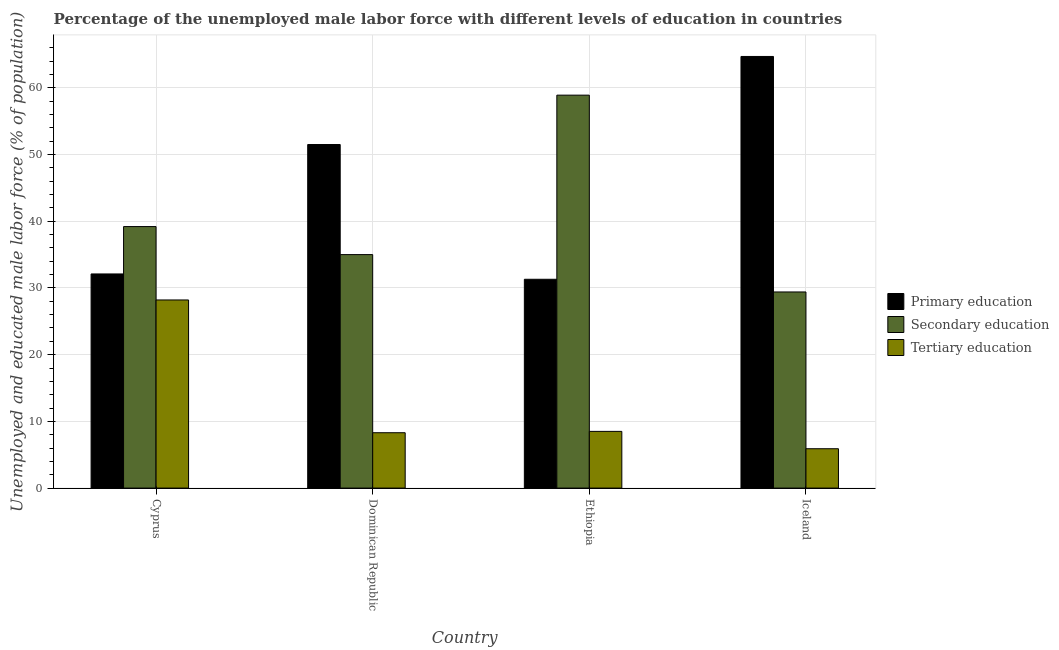How many groups of bars are there?
Give a very brief answer. 4. How many bars are there on the 3rd tick from the left?
Offer a very short reply. 3. In how many cases, is the number of bars for a given country not equal to the number of legend labels?
Provide a short and direct response. 0. What is the percentage of male labor force who received tertiary education in Dominican Republic?
Give a very brief answer. 8.3. Across all countries, what is the maximum percentage of male labor force who received primary education?
Your response must be concise. 64.7. Across all countries, what is the minimum percentage of male labor force who received tertiary education?
Provide a succinct answer. 5.9. In which country was the percentage of male labor force who received secondary education maximum?
Your answer should be compact. Ethiopia. What is the total percentage of male labor force who received primary education in the graph?
Your answer should be compact. 179.6. What is the difference between the percentage of male labor force who received primary education in Cyprus and that in Dominican Republic?
Your response must be concise. -19.4. What is the difference between the percentage of male labor force who received tertiary education in Cyprus and the percentage of male labor force who received primary education in Dominican Republic?
Ensure brevity in your answer.  -23.3. What is the average percentage of male labor force who received primary education per country?
Give a very brief answer. 44.9. What is the difference between the percentage of male labor force who received primary education and percentage of male labor force who received secondary education in Ethiopia?
Ensure brevity in your answer.  -27.6. What is the ratio of the percentage of male labor force who received tertiary education in Dominican Republic to that in Iceland?
Ensure brevity in your answer.  1.41. Is the percentage of male labor force who received secondary education in Cyprus less than that in Iceland?
Your answer should be compact. No. What is the difference between the highest and the second highest percentage of male labor force who received secondary education?
Your answer should be very brief. 19.7. What is the difference between the highest and the lowest percentage of male labor force who received secondary education?
Keep it short and to the point. 29.5. In how many countries, is the percentage of male labor force who received tertiary education greater than the average percentage of male labor force who received tertiary education taken over all countries?
Make the answer very short. 1. Is the sum of the percentage of male labor force who received tertiary education in Cyprus and Iceland greater than the maximum percentage of male labor force who received secondary education across all countries?
Give a very brief answer. No. What does the 1st bar from the left in Iceland represents?
Ensure brevity in your answer.  Primary education. What does the 3rd bar from the right in Iceland represents?
Make the answer very short. Primary education. How many bars are there?
Your answer should be very brief. 12. How many countries are there in the graph?
Your response must be concise. 4. Are the values on the major ticks of Y-axis written in scientific E-notation?
Your response must be concise. No. Does the graph contain any zero values?
Keep it short and to the point. No. How many legend labels are there?
Offer a very short reply. 3. What is the title of the graph?
Provide a succinct answer. Percentage of the unemployed male labor force with different levels of education in countries. Does "Ages 50+" appear as one of the legend labels in the graph?
Provide a succinct answer. No. What is the label or title of the X-axis?
Give a very brief answer. Country. What is the label or title of the Y-axis?
Offer a very short reply. Unemployed and educated male labor force (% of population). What is the Unemployed and educated male labor force (% of population) of Primary education in Cyprus?
Make the answer very short. 32.1. What is the Unemployed and educated male labor force (% of population) in Secondary education in Cyprus?
Provide a short and direct response. 39.2. What is the Unemployed and educated male labor force (% of population) of Tertiary education in Cyprus?
Your answer should be compact. 28.2. What is the Unemployed and educated male labor force (% of population) in Primary education in Dominican Republic?
Give a very brief answer. 51.5. What is the Unemployed and educated male labor force (% of population) in Secondary education in Dominican Republic?
Your answer should be very brief. 35. What is the Unemployed and educated male labor force (% of population) in Tertiary education in Dominican Republic?
Your answer should be compact. 8.3. What is the Unemployed and educated male labor force (% of population) of Primary education in Ethiopia?
Give a very brief answer. 31.3. What is the Unemployed and educated male labor force (% of population) in Secondary education in Ethiopia?
Your response must be concise. 58.9. What is the Unemployed and educated male labor force (% of population) in Tertiary education in Ethiopia?
Your answer should be very brief. 8.5. What is the Unemployed and educated male labor force (% of population) in Primary education in Iceland?
Ensure brevity in your answer.  64.7. What is the Unemployed and educated male labor force (% of population) in Secondary education in Iceland?
Give a very brief answer. 29.4. What is the Unemployed and educated male labor force (% of population) in Tertiary education in Iceland?
Provide a short and direct response. 5.9. Across all countries, what is the maximum Unemployed and educated male labor force (% of population) in Primary education?
Your response must be concise. 64.7. Across all countries, what is the maximum Unemployed and educated male labor force (% of population) of Secondary education?
Ensure brevity in your answer.  58.9. Across all countries, what is the maximum Unemployed and educated male labor force (% of population) in Tertiary education?
Your response must be concise. 28.2. Across all countries, what is the minimum Unemployed and educated male labor force (% of population) of Primary education?
Your answer should be very brief. 31.3. Across all countries, what is the minimum Unemployed and educated male labor force (% of population) in Secondary education?
Your answer should be very brief. 29.4. Across all countries, what is the minimum Unemployed and educated male labor force (% of population) of Tertiary education?
Your response must be concise. 5.9. What is the total Unemployed and educated male labor force (% of population) in Primary education in the graph?
Offer a terse response. 179.6. What is the total Unemployed and educated male labor force (% of population) of Secondary education in the graph?
Give a very brief answer. 162.5. What is the total Unemployed and educated male labor force (% of population) of Tertiary education in the graph?
Offer a terse response. 50.9. What is the difference between the Unemployed and educated male labor force (% of population) of Primary education in Cyprus and that in Dominican Republic?
Provide a short and direct response. -19.4. What is the difference between the Unemployed and educated male labor force (% of population) of Secondary education in Cyprus and that in Dominican Republic?
Your response must be concise. 4.2. What is the difference between the Unemployed and educated male labor force (% of population) in Secondary education in Cyprus and that in Ethiopia?
Your response must be concise. -19.7. What is the difference between the Unemployed and educated male labor force (% of population) of Primary education in Cyprus and that in Iceland?
Provide a short and direct response. -32.6. What is the difference between the Unemployed and educated male labor force (% of population) of Tertiary education in Cyprus and that in Iceland?
Your answer should be very brief. 22.3. What is the difference between the Unemployed and educated male labor force (% of population) of Primary education in Dominican Republic and that in Ethiopia?
Keep it short and to the point. 20.2. What is the difference between the Unemployed and educated male labor force (% of population) of Secondary education in Dominican Republic and that in Ethiopia?
Make the answer very short. -23.9. What is the difference between the Unemployed and educated male labor force (% of population) in Primary education in Dominican Republic and that in Iceland?
Your response must be concise. -13.2. What is the difference between the Unemployed and educated male labor force (% of population) in Primary education in Ethiopia and that in Iceland?
Your response must be concise. -33.4. What is the difference between the Unemployed and educated male labor force (% of population) in Secondary education in Ethiopia and that in Iceland?
Keep it short and to the point. 29.5. What is the difference between the Unemployed and educated male labor force (% of population) of Tertiary education in Ethiopia and that in Iceland?
Give a very brief answer. 2.6. What is the difference between the Unemployed and educated male labor force (% of population) in Primary education in Cyprus and the Unemployed and educated male labor force (% of population) in Secondary education in Dominican Republic?
Your response must be concise. -2.9. What is the difference between the Unemployed and educated male labor force (% of population) in Primary education in Cyprus and the Unemployed and educated male labor force (% of population) in Tertiary education in Dominican Republic?
Your answer should be compact. 23.8. What is the difference between the Unemployed and educated male labor force (% of population) in Secondary education in Cyprus and the Unemployed and educated male labor force (% of population) in Tertiary education in Dominican Republic?
Offer a terse response. 30.9. What is the difference between the Unemployed and educated male labor force (% of population) of Primary education in Cyprus and the Unemployed and educated male labor force (% of population) of Secondary education in Ethiopia?
Provide a short and direct response. -26.8. What is the difference between the Unemployed and educated male labor force (% of population) of Primary education in Cyprus and the Unemployed and educated male labor force (% of population) of Tertiary education in Ethiopia?
Make the answer very short. 23.6. What is the difference between the Unemployed and educated male labor force (% of population) in Secondary education in Cyprus and the Unemployed and educated male labor force (% of population) in Tertiary education in Ethiopia?
Provide a short and direct response. 30.7. What is the difference between the Unemployed and educated male labor force (% of population) in Primary education in Cyprus and the Unemployed and educated male labor force (% of population) in Secondary education in Iceland?
Give a very brief answer. 2.7. What is the difference between the Unemployed and educated male labor force (% of population) of Primary education in Cyprus and the Unemployed and educated male labor force (% of population) of Tertiary education in Iceland?
Your answer should be very brief. 26.2. What is the difference between the Unemployed and educated male labor force (% of population) of Secondary education in Cyprus and the Unemployed and educated male labor force (% of population) of Tertiary education in Iceland?
Offer a very short reply. 33.3. What is the difference between the Unemployed and educated male labor force (% of population) of Primary education in Dominican Republic and the Unemployed and educated male labor force (% of population) of Secondary education in Ethiopia?
Offer a terse response. -7.4. What is the difference between the Unemployed and educated male labor force (% of population) in Primary education in Dominican Republic and the Unemployed and educated male labor force (% of population) in Secondary education in Iceland?
Provide a short and direct response. 22.1. What is the difference between the Unemployed and educated male labor force (% of population) in Primary education in Dominican Republic and the Unemployed and educated male labor force (% of population) in Tertiary education in Iceland?
Keep it short and to the point. 45.6. What is the difference between the Unemployed and educated male labor force (% of population) of Secondary education in Dominican Republic and the Unemployed and educated male labor force (% of population) of Tertiary education in Iceland?
Provide a short and direct response. 29.1. What is the difference between the Unemployed and educated male labor force (% of population) of Primary education in Ethiopia and the Unemployed and educated male labor force (% of population) of Secondary education in Iceland?
Keep it short and to the point. 1.9. What is the difference between the Unemployed and educated male labor force (% of population) in Primary education in Ethiopia and the Unemployed and educated male labor force (% of population) in Tertiary education in Iceland?
Your answer should be very brief. 25.4. What is the difference between the Unemployed and educated male labor force (% of population) in Secondary education in Ethiopia and the Unemployed and educated male labor force (% of population) in Tertiary education in Iceland?
Provide a succinct answer. 53. What is the average Unemployed and educated male labor force (% of population) in Primary education per country?
Give a very brief answer. 44.9. What is the average Unemployed and educated male labor force (% of population) of Secondary education per country?
Your response must be concise. 40.62. What is the average Unemployed and educated male labor force (% of population) in Tertiary education per country?
Offer a very short reply. 12.72. What is the difference between the Unemployed and educated male labor force (% of population) of Primary education and Unemployed and educated male labor force (% of population) of Tertiary education in Dominican Republic?
Provide a short and direct response. 43.2. What is the difference between the Unemployed and educated male labor force (% of population) of Secondary education and Unemployed and educated male labor force (% of population) of Tertiary education in Dominican Republic?
Give a very brief answer. 26.7. What is the difference between the Unemployed and educated male labor force (% of population) in Primary education and Unemployed and educated male labor force (% of population) in Secondary education in Ethiopia?
Your answer should be very brief. -27.6. What is the difference between the Unemployed and educated male labor force (% of population) of Primary education and Unemployed and educated male labor force (% of population) of Tertiary education in Ethiopia?
Your answer should be very brief. 22.8. What is the difference between the Unemployed and educated male labor force (% of population) in Secondary education and Unemployed and educated male labor force (% of population) in Tertiary education in Ethiopia?
Your answer should be very brief. 50.4. What is the difference between the Unemployed and educated male labor force (% of population) of Primary education and Unemployed and educated male labor force (% of population) of Secondary education in Iceland?
Offer a terse response. 35.3. What is the difference between the Unemployed and educated male labor force (% of population) of Primary education and Unemployed and educated male labor force (% of population) of Tertiary education in Iceland?
Make the answer very short. 58.8. What is the difference between the Unemployed and educated male labor force (% of population) in Secondary education and Unemployed and educated male labor force (% of population) in Tertiary education in Iceland?
Provide a succinct answer. 23.5. What is the ratio of the Unemployed and educated male labor force (% of population) in Primary education in Cyprus to that in Dominican Republic?
Provide a short and direct response. 0.62. What is the ratio of the Unemployed and educated male labor force (% of population) of Secondary education in Cyprus to that in Dominican Republic?
Make the answer very short. 1.12. What is the ratio of the Unemployed and educated male labor force (% of population) of Tertiary education in Cyprus to that in Dominican Republic?
Provide a succinct answer. 3.4. What is the ratio of the Unemployed and educated male labor force (% of population) of Primary education in Cyprus to that in Ethiopia?
Offer a very short reply. 1.03. What is the ratio of the Unemployed and educated male labor force (% of population) of Secondary education in Cyprus to that in Ethiopia?
Offer a very short reply. 0.67. What is the ratio of the Unemployed and educated male labor force (% of population) of Tertiary education in Cyprus to that in Ethiopia?
Provide a succinct answer. 3.32. What is the ratio of the Unemployed and educated male labor force (% of population) in Primary education in Cyprus to that in Iceland?
Keep it short and to the point. 0.5. What is the ratio of the Unemployed and educated male labor force (% of population) of Secondary education in Cyprus to that in Iceland?
Your response must be concise. 1.33. What is the ratio of the Unemployed and educated male labor force (% of population) in Tertiary education in Cyprus to that in Iceland?
Your answer should be very brief. 4.78. What is the ratio of the Unemployed and educated male labor force (% of population) in Primary education in Dominican Republic to that in Ethiopia?
Ensure brevity in your answer.  1.65. What is the ratio of the Unemployed and educated male labor force (% of population) in Secondary education in Dominican Republic to that in Ethiopia?
Provide a short and direct response. 0.59. What is the ratio of the Unemployed and educated male labor force (% of population) of Tertiary education in Dominican Republic to that in Ethiopia?
Provide a short and direct response. 0.98. What is the ratio of the Unemployed and educated male labor force (% of population) of Primary education in Dominican Republic to that in Iceland?
Offer a terse response. 0.8. What is the ratio of the Unemployed and educated male labor force (% of population) of Secondary education in Dominican Republic to that in Iceland?
Your response must be concise. 1.19. What is the ratio of the Unemployed and educated male labor force (% of population) in Tertiary education in Dominican Republic to that in Iceland?
Keep it short and to the point. 1.41. What is the ratio of the Unemployed and educated male labor force (% of population) in Primary education in Ethiopia to that in Iceland?
Keep it short and to the point. 0.48. What is the ratio of the Unemployed and educated male labor force (% of population) of Secondary education in Ethiopia to that in Iceland?
Your answer should be very brief. 2. What is the ratio of the Unemployed and educated male labor force (% of population) in Tertiary education in Ethiopia to that in Iceland?
Provide a short and direct response. 1.44. What is the difference between the highest and the second highest Unemployed and educated male labor force (% of population) of Primary education?
Make the answer very short. 13.2. What is the difference between the highest and the second highest Unemployed and educated male labor force (% of population) of Secondary education?
Your answer should be compact. 19.7. What is the difference between the highest and the lowest Unemployed and educated male labor force (% of population) in Primary education?
Make the answer very short. 33.4. What is the difference between the highest and the lowest Unemployed and educated male labor force (% of population) in Secondary education?
Offer a terse response. 29.5. What is the difference between the highest and the lowest Unemployed and educated male labor force (% of population) in Tertiary education?
Provide a succinct answer. 22.3. 